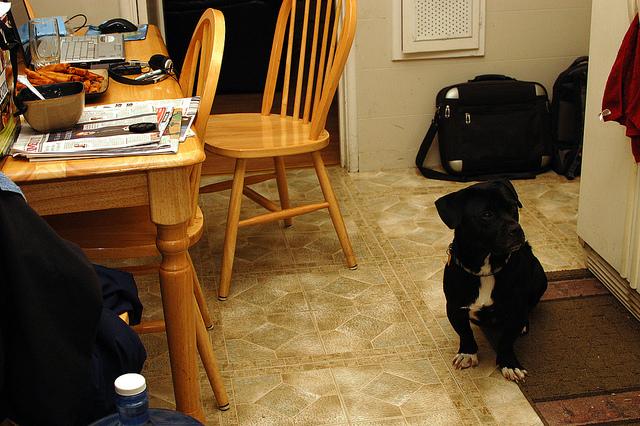How many chairs are there?
Write a very short answer. 2. Is this dog full grown?
Write a very short answer. No. What type of dish is on the table?
Write a very short answer. Bowl. 